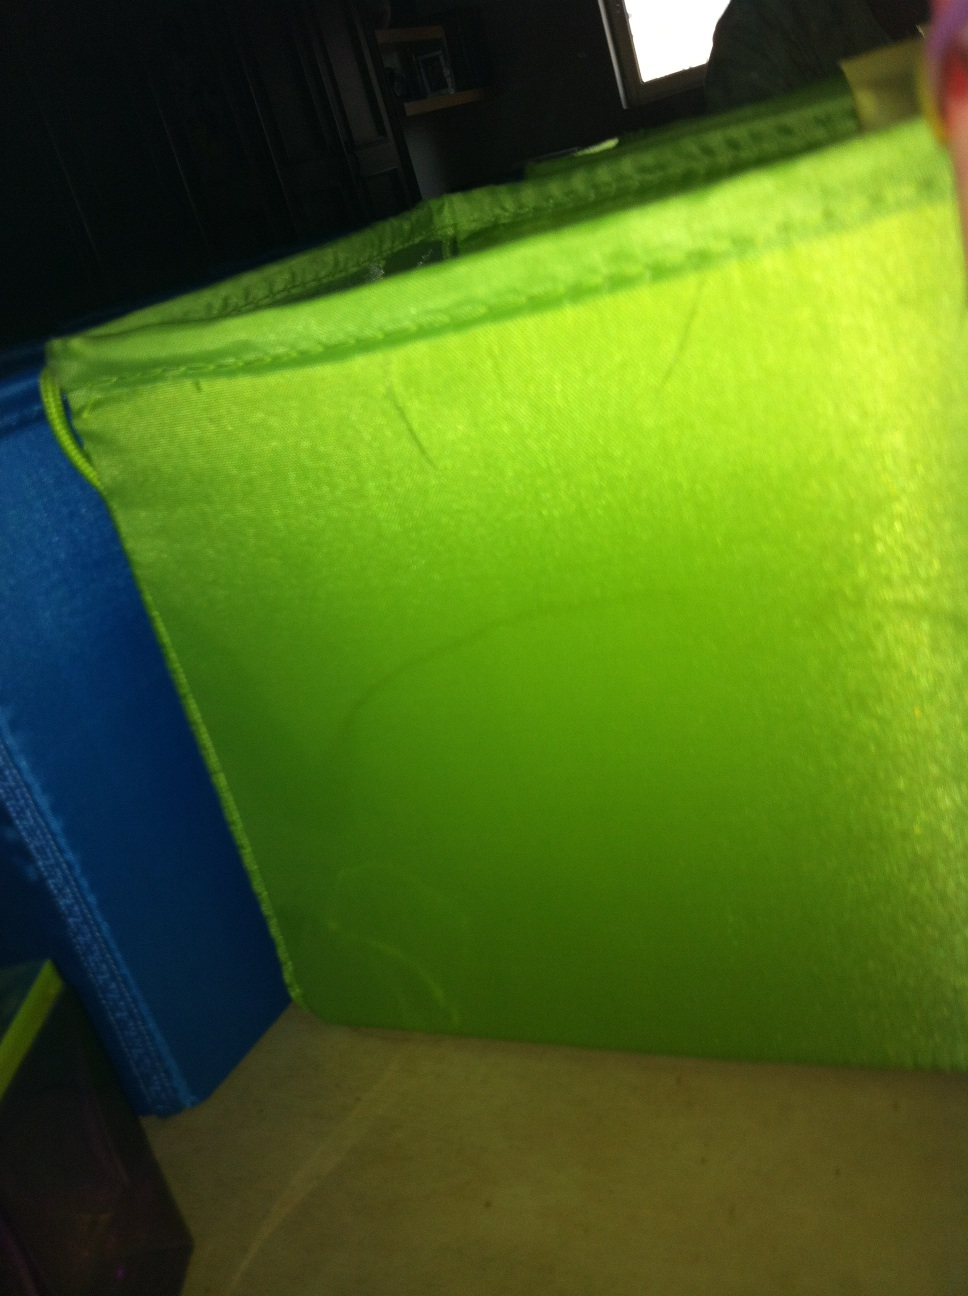What is this? from Vizwiz This appears to be a green container, possibly a storage bin or organizer, placed in a dimly lit setting. It is vibrant green and the surface texture suggests a fabric-like material, often used for collapsible storage units. The slight shininess indicates it might be slightly reflective or coated. 